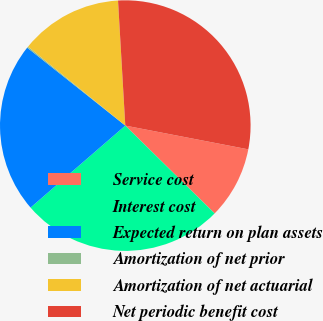Convert chart. <chart><loc_0><loc_0><loc_500><loc_500><pie_chart><fcel>Service cost<fcel>Interest cost<fcel>Expected return on plan assets<fcel>Amortization of net prior<fcel>Amortization of net actuarial<fcel>Net periodic benefit cost<nl><fcel>9.33%<fcel>26.28%<fcel>22.04%<fcel>0.17%<fcel>13.22%<fcel>28.96%<nl></chart> 